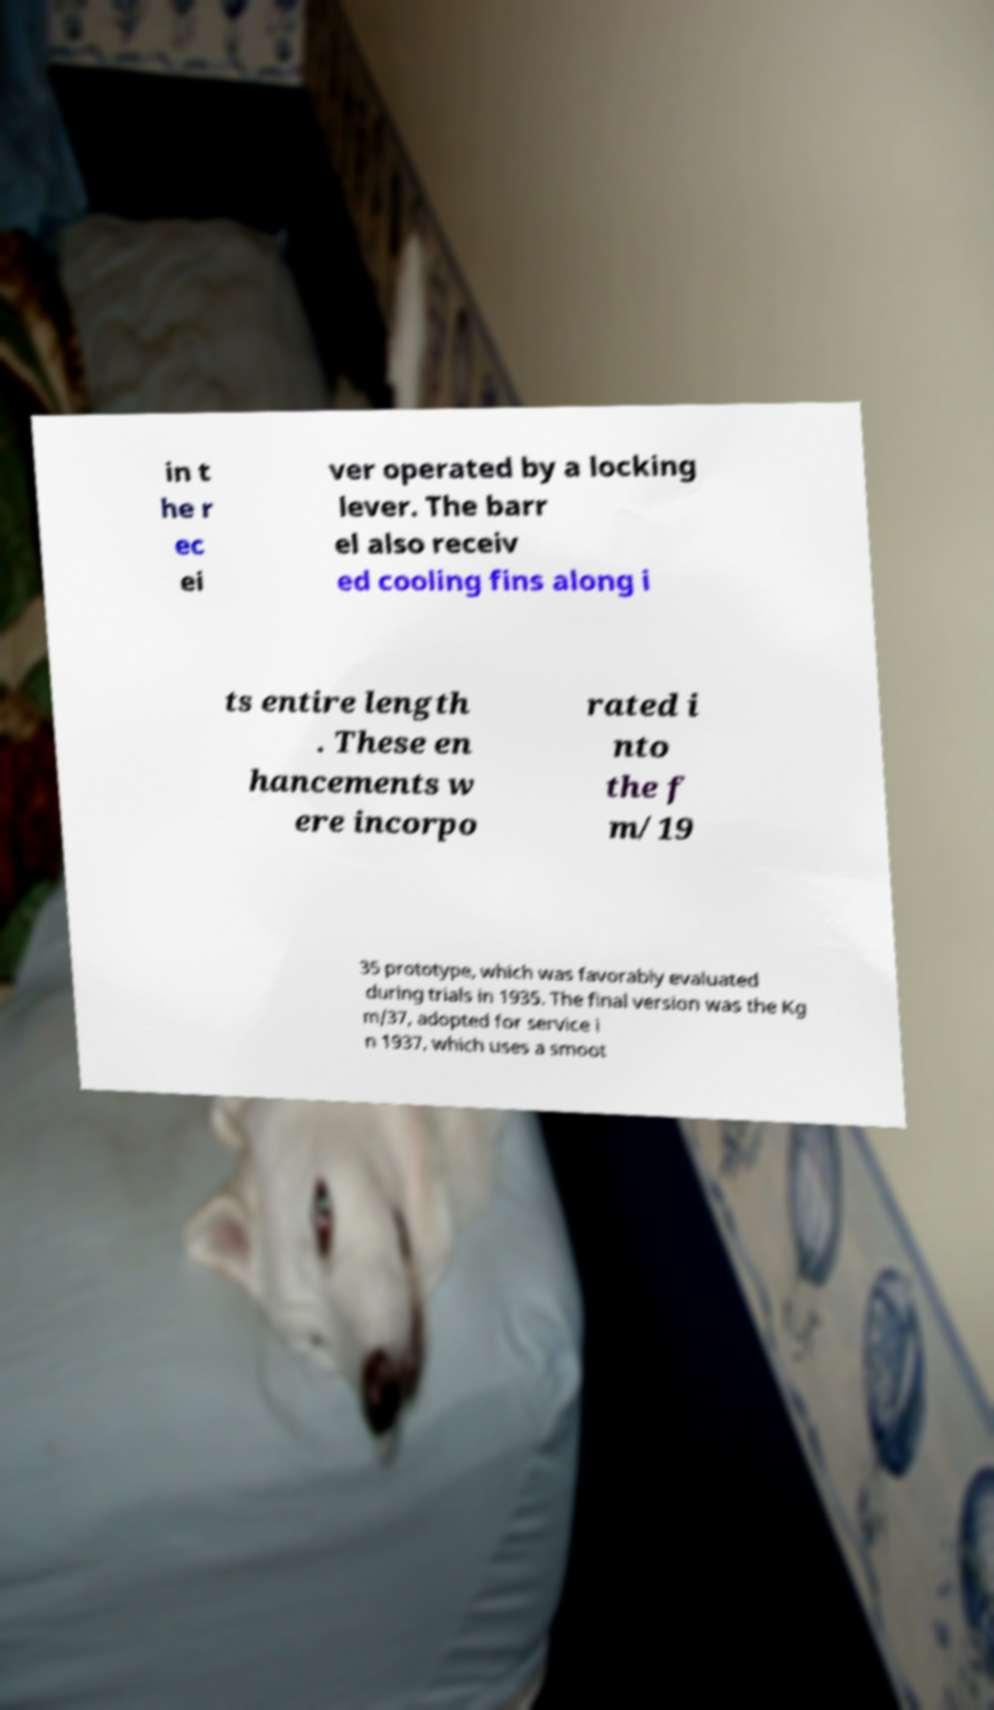Could you assist in decoding the text presented in this image and type it out clearly? in t he r ec ei ver operated by a locking lever. The barr el also receiv ed cooling fins along i ts entire length . These en hancements w ere incorpo rated i nto the f m/19 35 prototype, which was favorably evaluated during trials in 1935. The final version was the Kg m/37, adopted for service i n 1937, which uses a smoot 